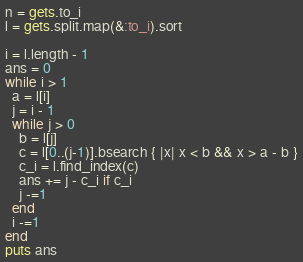Convert code to text. <code><loc_0><loc_0><loc_500><loc_500><_Ruby_>n = gets.to_i
l = gets.split.map(&:to_i).sort

i = l.length - 1
ans = 0
while i > 1
  a = l[i]
  j = i - 1
  while j > 0
    b = l[j]
    c = l[0..(j-1)].bsearch { |x| x < b && x > a - b }
    c_i = l.find_index(c)
    ans += j - c_i if c_i
    j -=1
  end
  i -=1
end
puts ans
</code> 